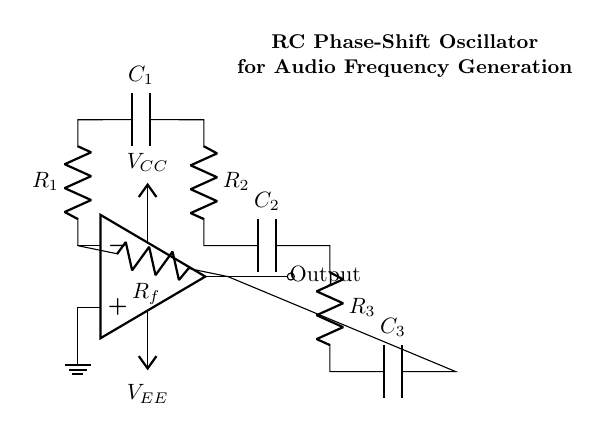What is the purpose of the op-amp in this circuit? The op-amp is used to amplify the signal and provide feedback necessary for oscillation. In oscillators, it generates the required output waveform based on the feedback from the RC network.
Answer: Amplification What type of components are R1, R2, R3, and Rf? R1, R2, R3, and Rf are resistors used for controlling the gain and feedback in the oscillator circuit. Their values determine the frequency of oscillation and the stability of the output waveform.
Answer: Resistors How many capacitors are in the RC network? There are three capacitors in the RC network (C1, C2, C3) which help in establishing the phase shifts required for oscillation. Each capacitor is connected sequentially to achieve the desired phase shift of 180 degrees cumulatively.
Answer: Three What is the function of the feedback resistor Rf? The feedback resistor Rf connects the output of the op-amp back to the inverting input, providing the necessary feedback for sustained oscillation. This feedback also affects the gain of the op-amp, influencing the overall circuit behavior.
Answer: Feedback What is the expected output frequency range for this RC phase-shift oscillator? The output frequency is determined by the values of the resistors and capacitors in the circuit. Generally, this type of oscillator is used in audio applications, typically generating frequencies in the range of several hundred Hz to a few kHz, depending on the component values.
Answer: Audio frequency range What role do the capacitors play in this oscillator? The capacitors introduce phase shifts in the circuit, essential for achieving the total phase shift of 360 degrees among all components, which allows the oscillation to occur. Without them, the circuit would not self-sustain oscillations.
Answer: Phase shift 